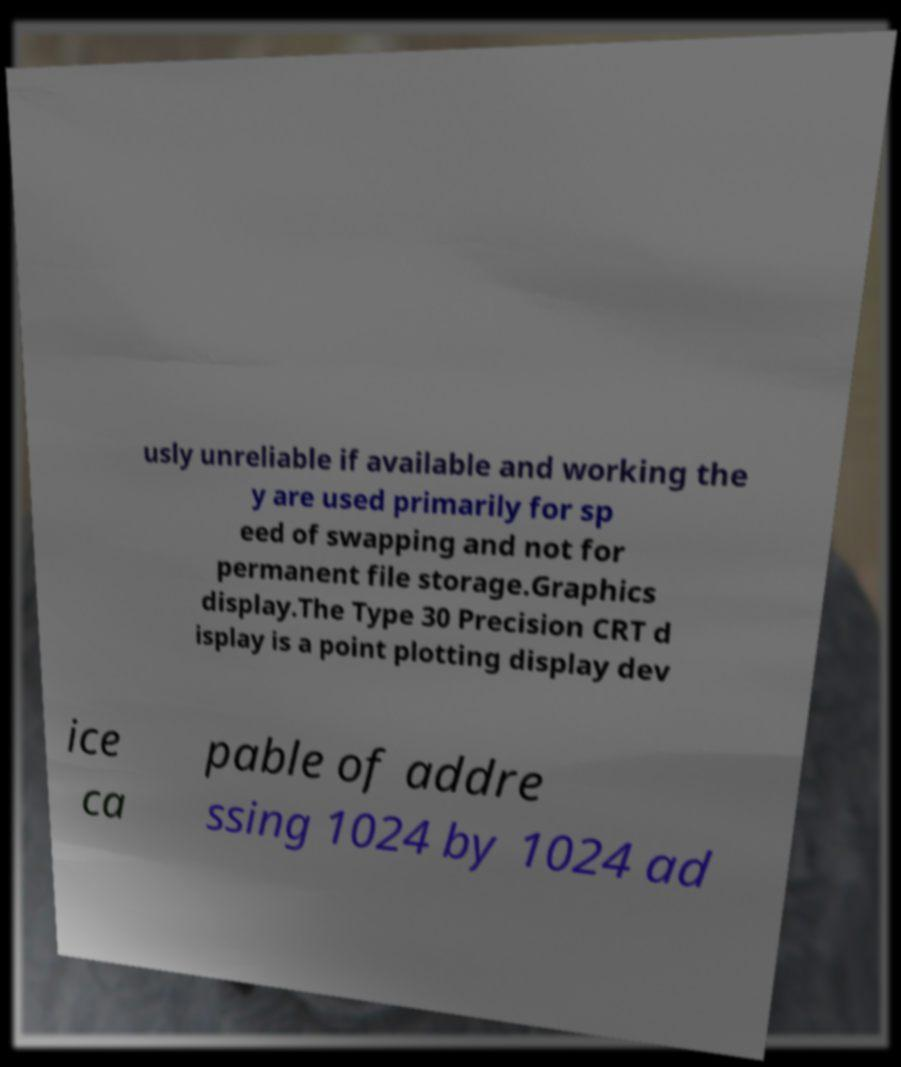Please read and relay the text visible in this image. What does it say? usly unreliable if available and working the y are used primarily for sp eed of swapping and not for permanent file storage.Graphics display.The Type 30 Precision CRT d isplay is a point plotting display dev ice ca pable of addre ssing 1024 by 1024 ad 